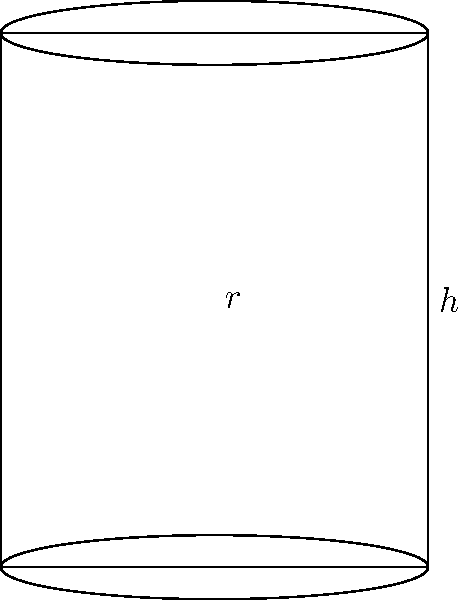A bank is planning to install new cylindrical money vaults in its branches. Each vault has a radius of 2 meters and a height of 5 meters. As a banking officer working with accountants, you need to calculate the total surface area of each vault for security coating purposes. What is the total surface area of one cylindrical vault in square meters? (Use $\pi = 3.14$ for calculations) To calculate the total surface area of a cylindrical vault, we need to consider three parts:

1. The lateral surface area (side of the cylinder)
2. The area of the top circular face
3. The area of the bottom circular face

Let's calculate each part:

1. Lateral surface area:
   $A_{\text{lateral}} = 2\pi rh$
   $A_{\text{lateral}} = 2 \times 3.14 \times 2 \times 5 = 62.8$ m²

2. Area of the top circular face:
   $A_{\text{top}} = \pi r^2$
   $A_{\text{top}} = 3.14 \times 2^2 = 12.56$ m²

3. Area of the bottom circular face:
   $A_{\text{bottom}} = \pi r^2$
   $A_{\text{bottom}} = 3.14 \times 2^2 = 12.56$ m²

Now, we sum up all three parts:

Total surface area = $A_{\text{lateral}} + A_{\text{top}} + A_{\text{bottom}}$
Total surface area = $62.8 + 12.56 + 12.56 = 87.92$ m²
Answer: 87.92 m² 